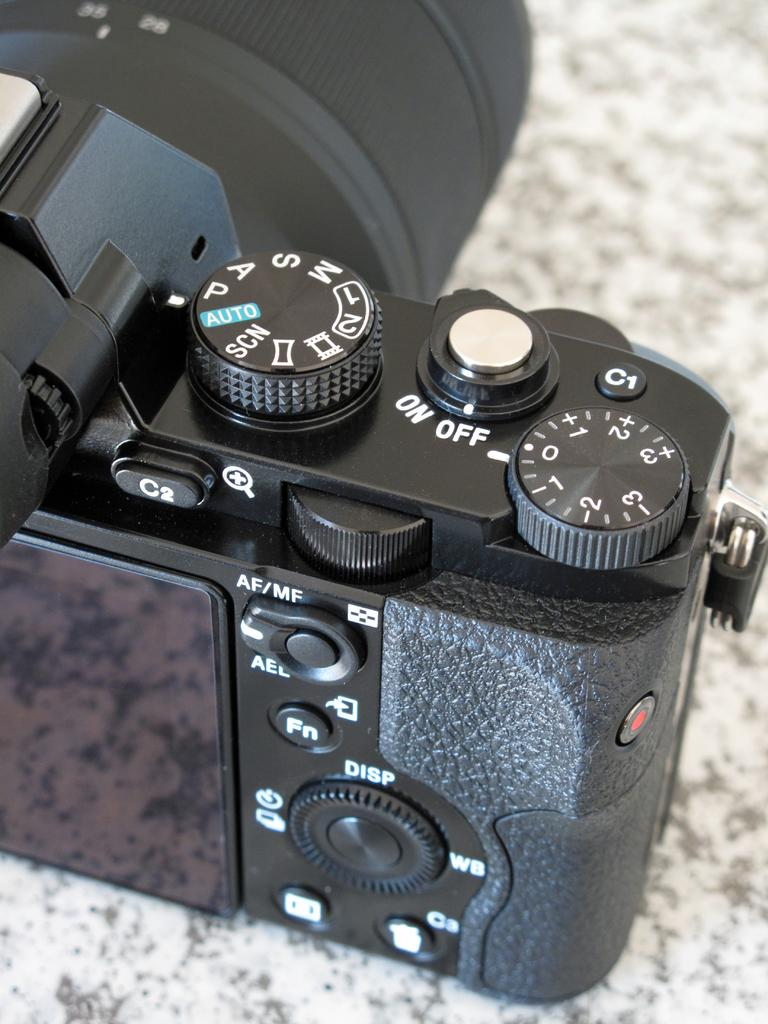What is the main subject of the image? The main subject of the image is a camera. Where is the camera located in the image? The camera is placed on an object. What additional information can be seen on the camera? There is text and numbers on the camera. Can you tell me how many potatoes are in the image? There are no potatoes present in the image; it features a camera placed on an object with text and numbers. 